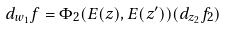Convert formula to latex. <formula><loc_0><loc_0><loc_500><loc_500>d _ { w _ { 1 } } f = \Phi _ { 2 } ( E ( z ) , E ( z ^ { \prime } ) ) ( d _ { z _ { 2 } } f _ { 2 } )</formula> 